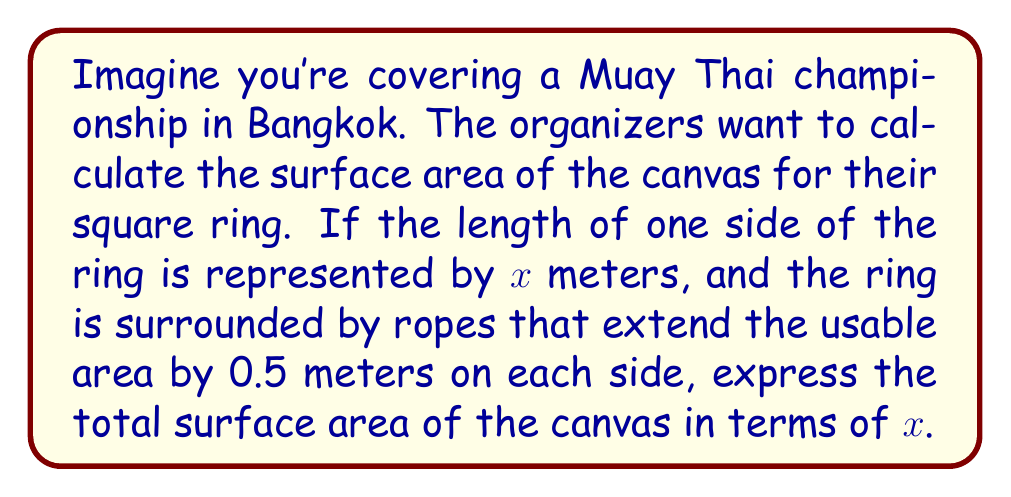Show me your answer to this math problem. Let's approach this step-by-step:

1) The actual fighting area of the ring is a square with side length $x$ meters.

2) The ropes extend the usable area by 0.5 meters on each side. This means we need to add 1 meter (0.5 m on each side) to the length and width of the ring.

3) The total length of one side of the canvas will be:
   $$(x + 1)$$ meters

4) The surface area of a square is given by the formula:
   $$A = s^2$$
   where $A$ is the area and $s$ is the side length.

5) Substituting our side length into this formula:
   $$A = (x + 1)^2$$

6) Expanding this expression:
   $$A = x^2 + 2x + 1$$

Therefore, the surface area of the canvas in square meters is represented by the algebraic expression $x^2 + 2x + 1$.
Answer: $x^2 + 2x + 1$ square meters 